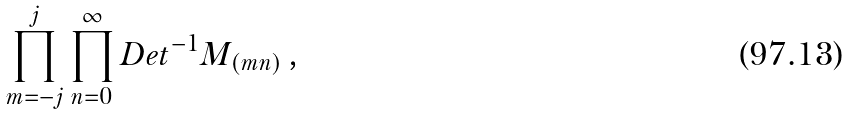<formula> <loc_0><loc_0><loc_500><loc_500>\prod ^ { j } _ { m = - j } \prod ^ { \infty } _ { n = 0 } D e t ^ { - 1 } M _ { ( m n ) } \, ,</formula> 